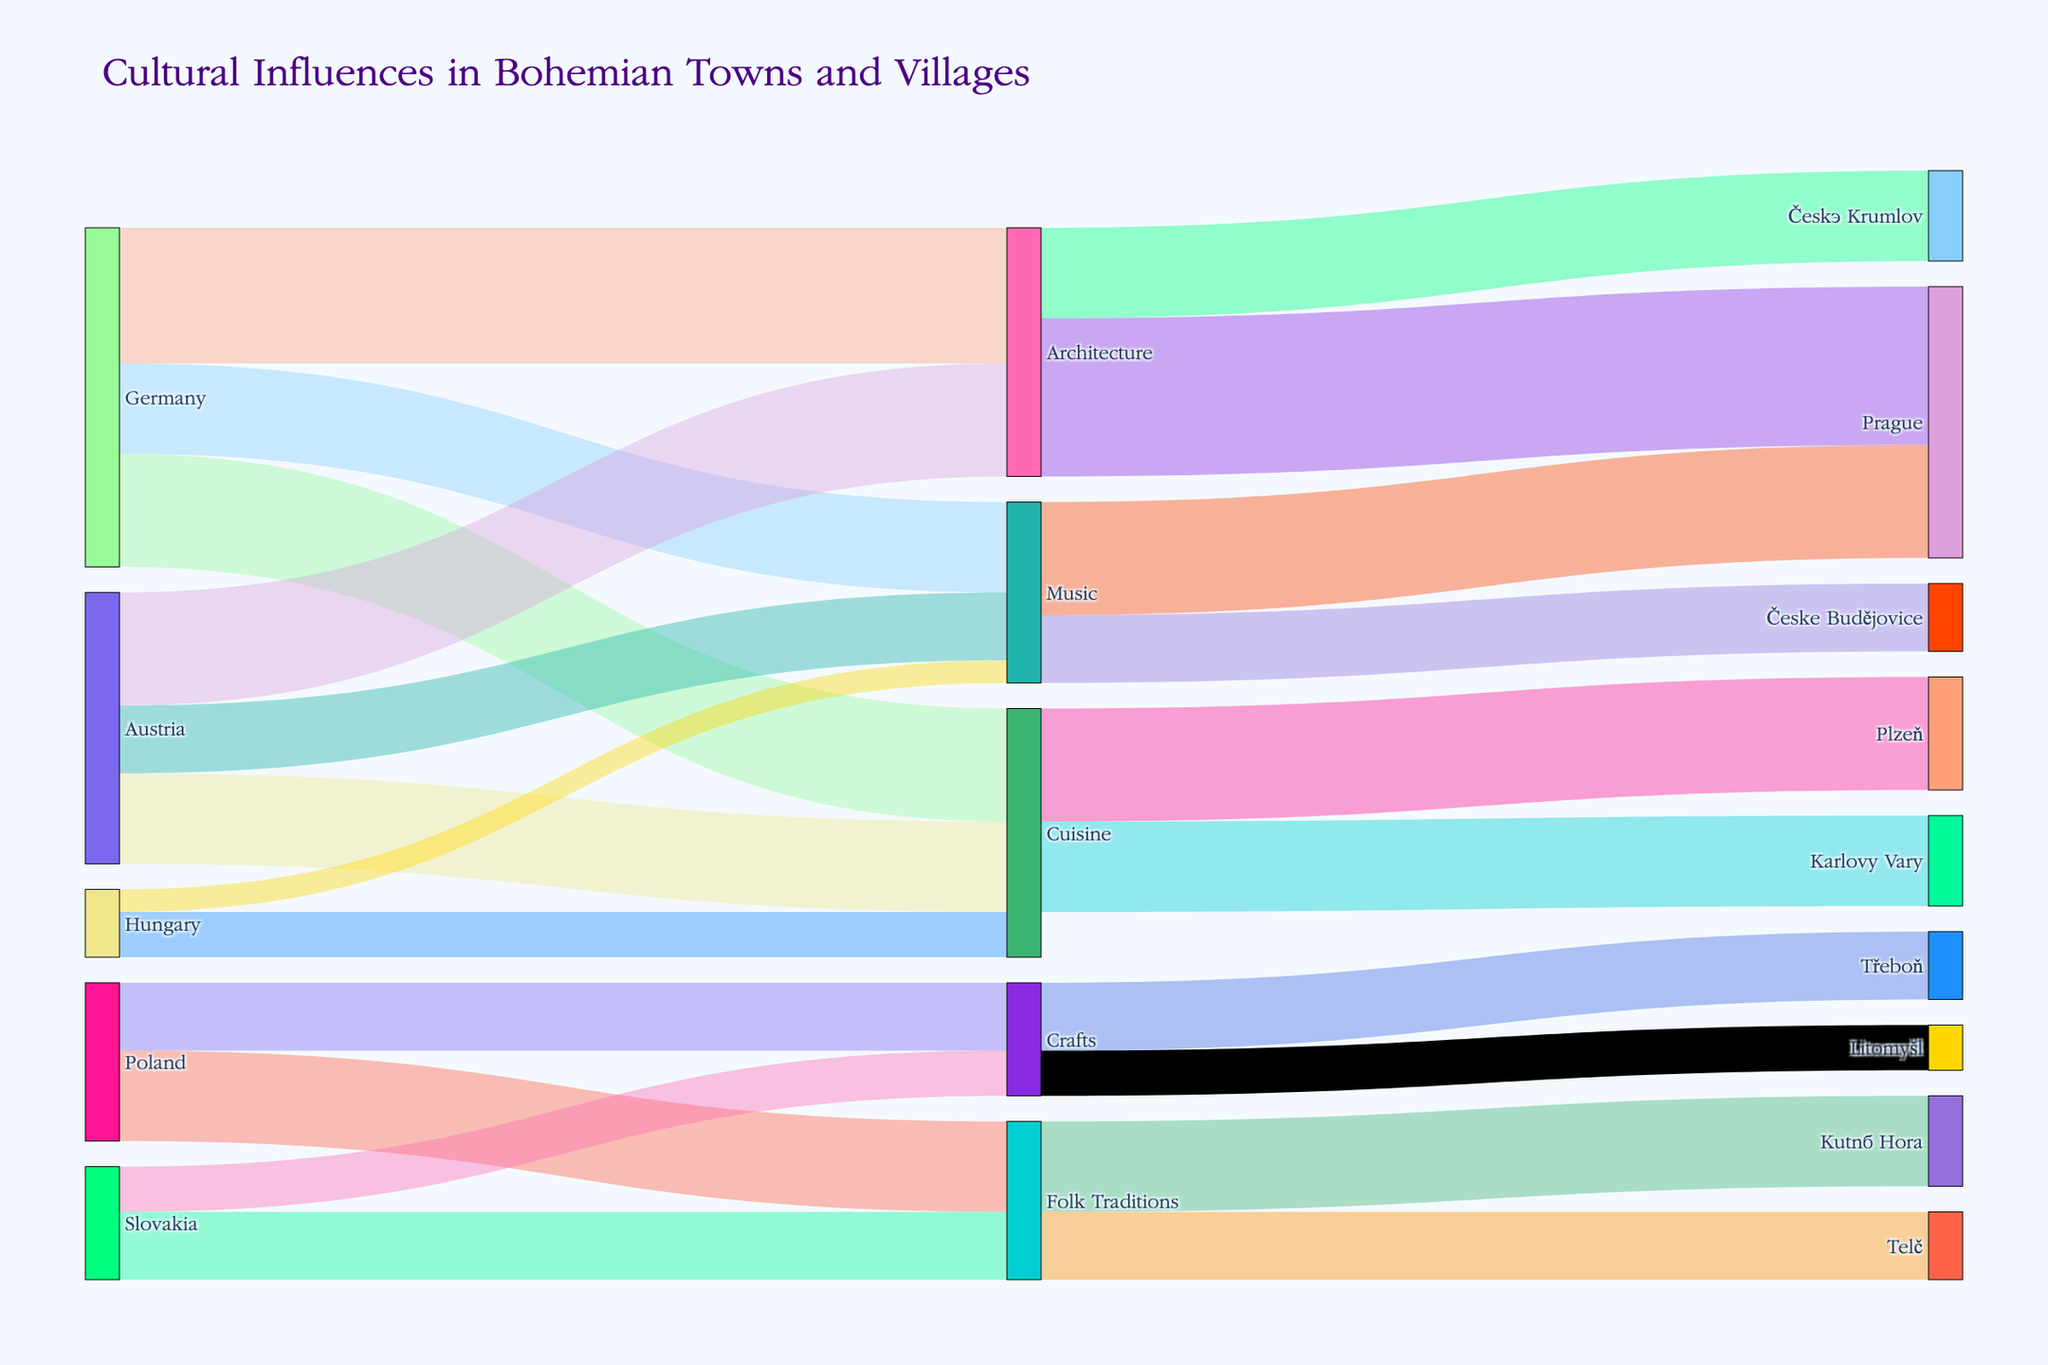What is the title of the Sankey Diagram? The title of the figure is typically located at the top and provides an overview of what the visual represents. In this case, the title is "Cultural Influences in Bohemian Towns and Villages."
Answer: Cultural Influences in Bohemian Towns and Villages What two cultural aspects does Germany influence the most in Bohemian towns and villages? To answer this, look at the nodes connected to Germany and identify the highest values associated with them. Germany’s highest values are with Architecture (30) and Cuisine (25).
Answer: Architecture, Cuisine Which town receives the highest influence in Architecture from neighboring countries? Observe the target nodes connected with Architecture and compare their values. The highest value (35) is associated with Prague.
Answer: Prague What is the total cultural influence of Germany and Austria in Architecture? Sum the values of Architecture influenced by Germany (30) and Austria (25). 30 + 25 equals 55.
Answer: 55 Compare the influence on Music from Germany and Hungary in Bohemian towns. Look at the values of Music influenced by Germany (20) and Hungary (5). Germany has a much higher influence.
Answer: Germany has more influence Which town benefits the least from influences in Crafts? Examine the nodes connected to Crafts and compare their values. The smallest value (10) connects to Litomyšl.
Answer: Litomyšl How much influence does Poland have on Folk Traditions compared to Slovakia? Compare the values associated with Folk Traditions from Poland (20) and Slovakia (15). Poland has 5 more units of influence.
Answer: Poland has more influence What are the cultural aspects influenced by both Germany and Austria? Identify the cultural aspects both Germany and Austria influence. Both influence Architecture, Cuisine, and Music.
Answer: Architecture, Cuisine, Music Which countries have no influence on Cuisine in Bohemian towns? Check the list of countries connected to Cuisine and see which ones are missing. Poland and Slovakia do not influence Cuisine.
Answer: Poland, Slovakia What is the combined influence of all countries on Folk Traditions? Add the values of Folk Traditions influenced by Poland (20) and Slovakia (15). The total is 35.
Answer: 35 